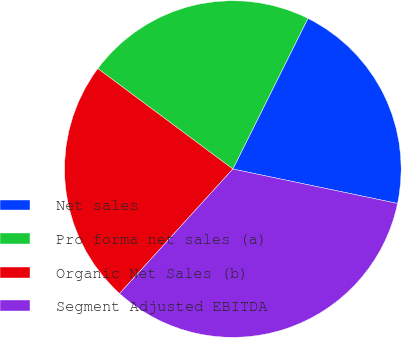Convert chart to OTSL. <chart><loc_0><loc_0><loc_500><loc_500><pie_chart><fcel>Net sales<fcel>Pro forma net sales (a)<fcel>Organic Net Sales (b)<fcel>Segment Adjusted EBITDA<nl><fcel>20.92%<fcel>22.18%<fcel>23.43%<fcel>33.47%<nl></chart> 